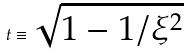Convert formula to latex. <formula><loc_0><loc_0><loc_500><loc_500>t \equiv \sqrt { 1 - 1 / \xi ^ { 2 } }</formula> 